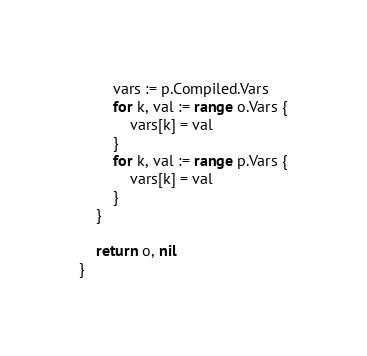Convert code to text. <code><loc_0><loc_0><loc_500><loc_500><_Go_>		vars := p.Compiled.Vars
		for k, val := range o.Vars {
			vars[k] = val
		}
		for k, val := range p.Vars {
			vars[k] = val
		}
	}

	return o, nil
}
</code> 